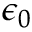Convert formula to latex. <formula><loc_0><loc_0><loc_500><loc_500>\epsilon _ { 0 }</formula> 